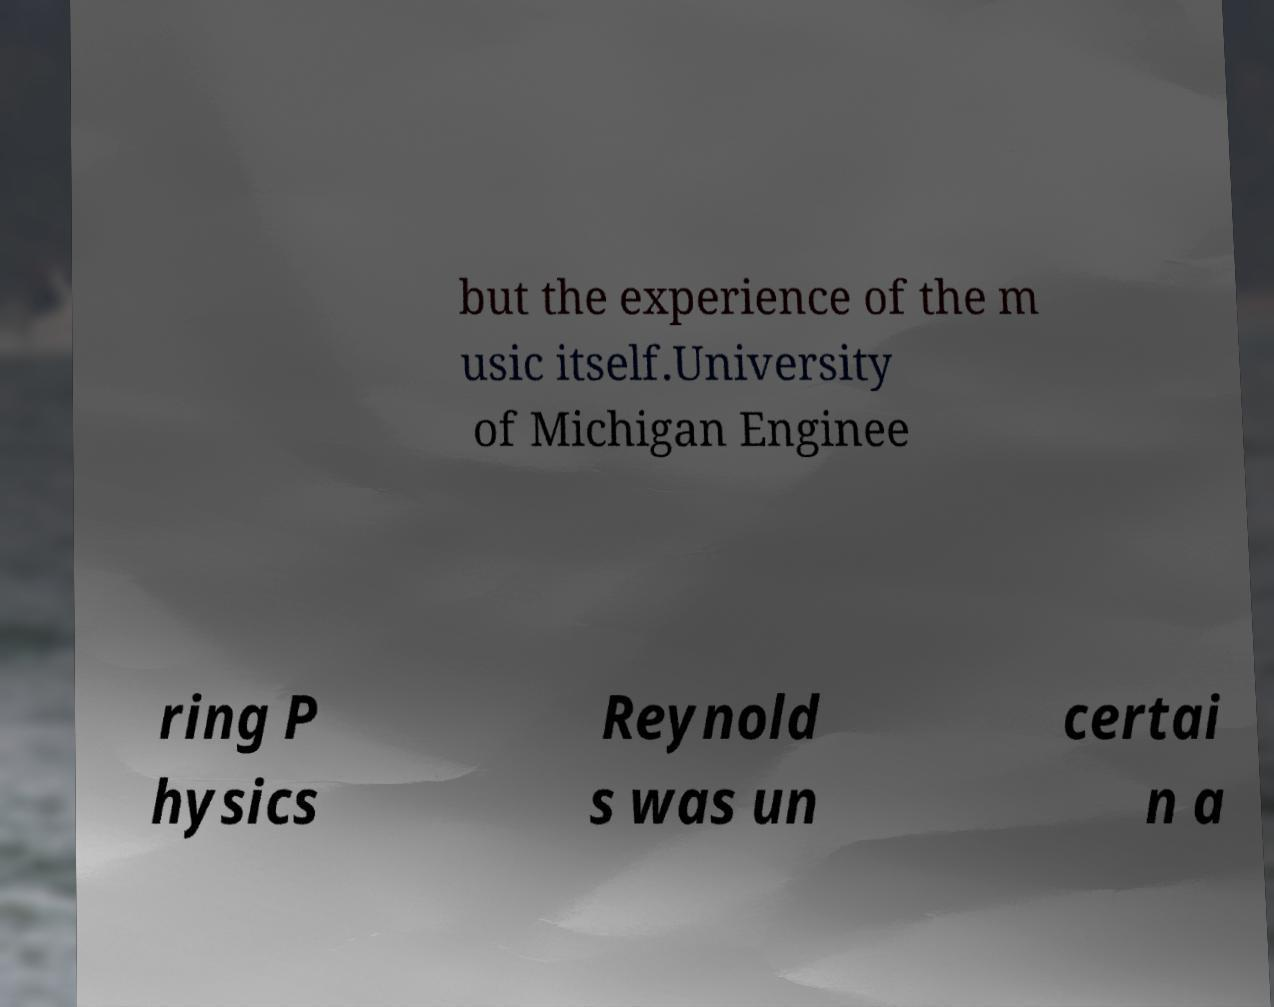For documentation purposes, I need the text within this image transcribed. Could you provide that? but the experience of the m usic itself.University of Michigan Enginee ring P hysics Reynold s was un certai n a 